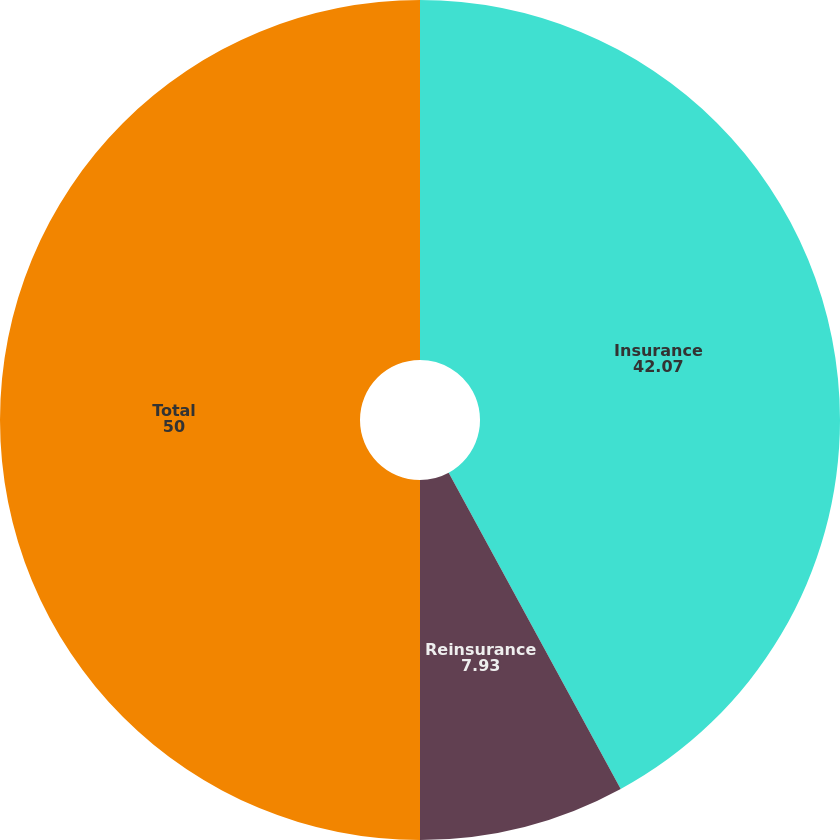Convert chart to OTSL. <chart><loc_0><loc_0><loc_500><loc_500><pie_chart><fcel>Insurance<fcel>Reinsurance<fcel>Total<nl><fcel>42.07%<fcel>7.93%<fcel>50.0%<nl></chart> 